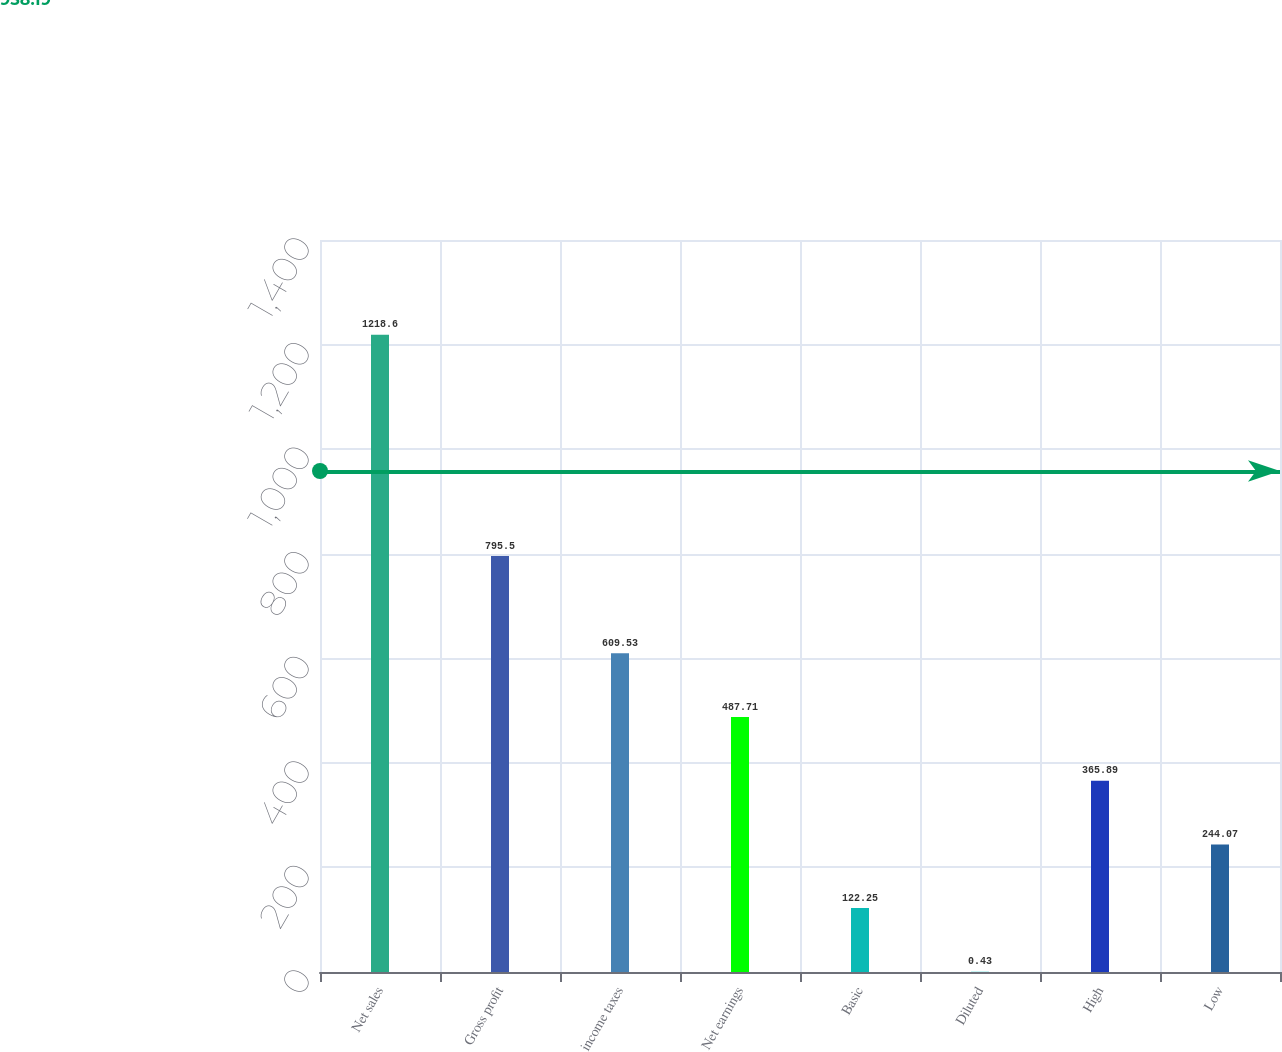<chart> <loc_0><loc_0><loc_500><loc_500><bar_chart><fcel>Net sales<fcel>Gross profit<fcel>income taxes<fcel>Net earnings<fcel>Basic<fcel>Diluted<fcel>High<fcel>Low<nl><fcel>1218.6<fcel>795.5<fcel>609.53<fcel>487.71<fcel>122.25<fcel>0.43<fcel>365.89<fcel>244.07<nl></chart> 